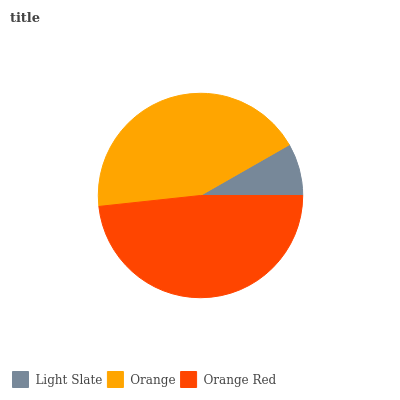Is Light Slate the minimum?
Answer yes or no. Yes. Is Orange Red the maximum?
Answer yes or no. Yes. Is Orange the minimum?
Answer yes or no. No. Is Orange the maximum?
Answer yes or no. No. Is Orange greater than Light Slate?
Answer yes or no. Yes. Is Light Slate less than Orange?
Answer yes or no. Yes. Is Light Slate greater than Orange?
Answer yes or no. No. Is Orange less than Light Slate?
Answer yes or no. No. Is Orange the high median?
Answer yes or no. Yes. Is Orange the low median?
Answer yes or no. Yes. Is Light Slate the high median?
Answer yes or no. No. Is Orange Red the low median?
Answer yes or no. No. 